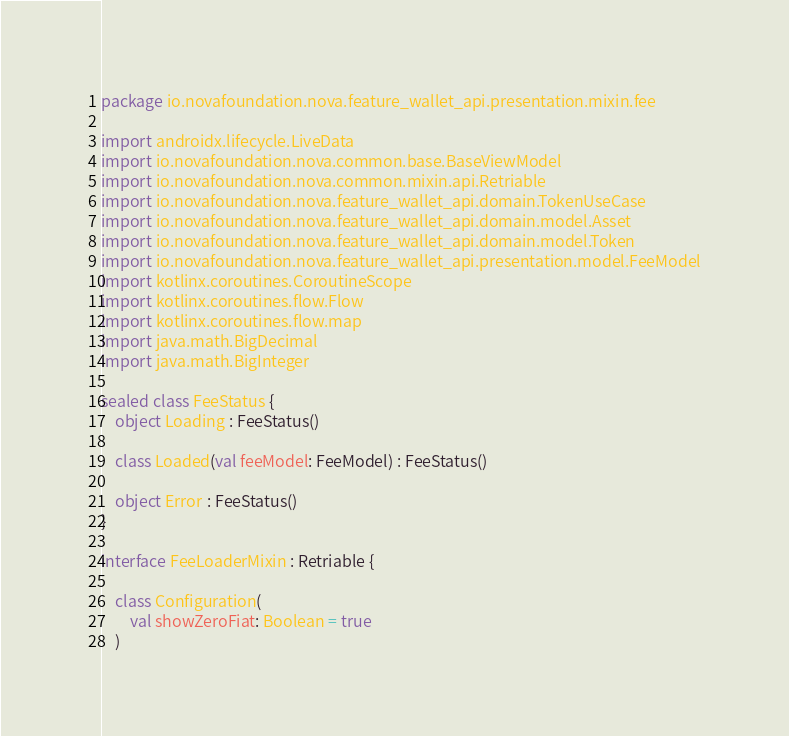<code> <loc_0><loc_0><loc_500><loc_500><_Kotlin_>package io.novafoundation.nova.feature_wallet_api.presentation.mixin.fee

import androidx.lifecycle.LiveData
import io.novafoundation.nova.common.base.BaseViewModel
import io.novafoundation.nova.common.mixin.api.Retriable
import io.novafoundation.nova.feature_wallet_api.domain.TokenUseCase
import io.novafoundation.nova.feature_wallet_api.domain.model.Asset
import io.novafoundation.nova.feature_wallet_api.domain.model.Token
import io.novafoundation.nova.feature_wallet_api.presentation.model.FeeModel
import kotlinx.coroutines.CoroutineScope
import kotlinx.coroutines.flow.Flow
import kotlinx.coroutines.flow.map
import java.math.BigDecimal
import java.math.BigInteger

sealed class FeeStatus {
    object Loading : FeeStatus()

    class Loaded(val feeModel: FeeModel) : FeeStatus()

    object Error : FeeStatus()
}

interface FeeLoaderMixin : Retriable {

    class Configuration(
        val showZeroFiat: Boolean = true
    )
</code> 